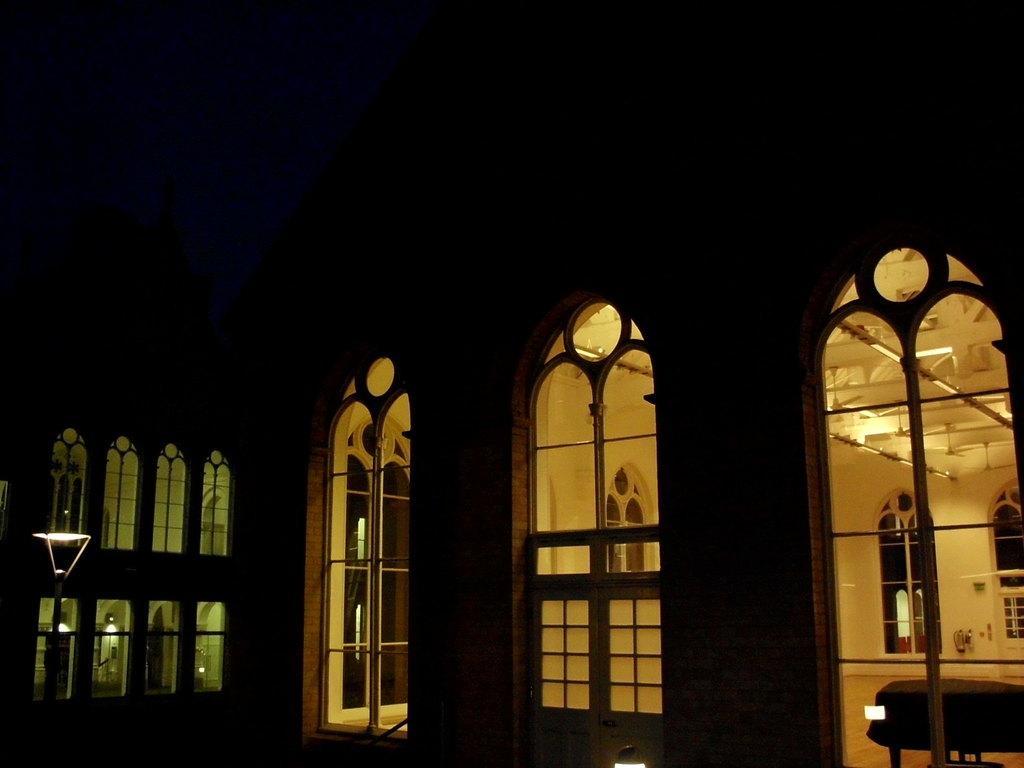Can you describe this image briefly? In this image there is a building with the windows. This image is taken in the nighttime. There are three windows in the middle. At the top there is ceiling with the lights. On the left side there are windows. In front of the windows there is a light. 